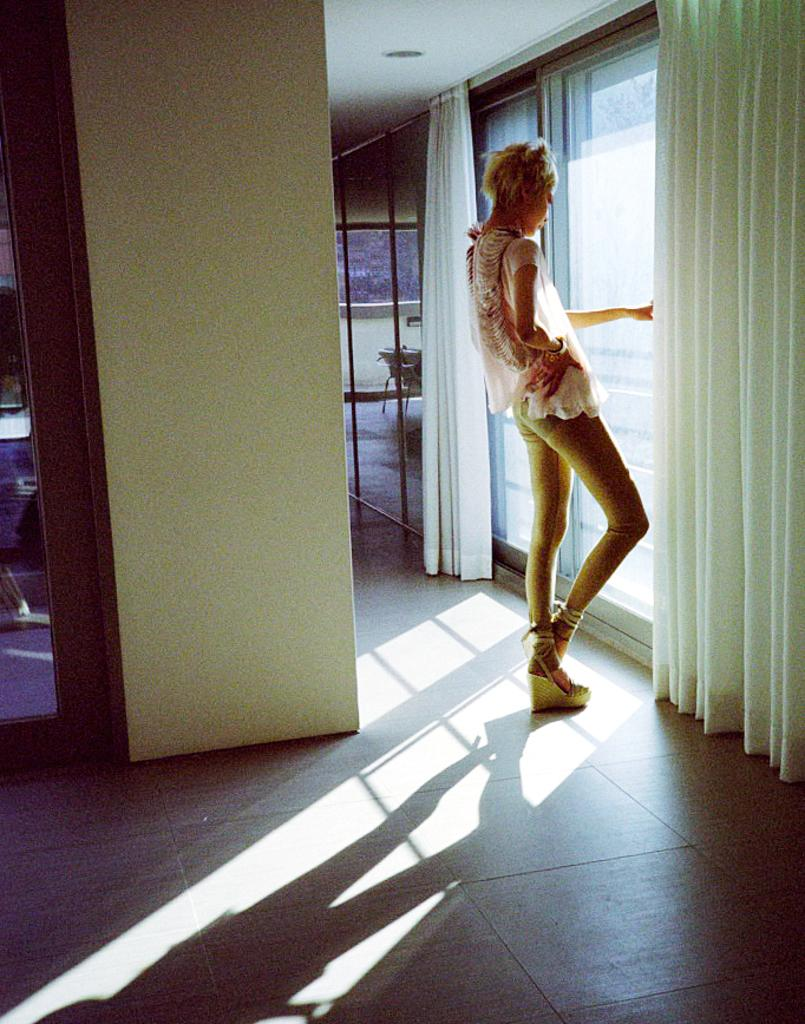What is the main subject in the image? There is a lady standing in the image. What can be seen on the left side of the image? There is a wall on the left side of the image. What is present on the right side of the image? There are windows on the right side of the image. What type of window treatment is visible in the image? There are curtains associated with the windows on the right side of the image. What type of hat is the lady wearing in the image? The lady is not wearing a hat in the image. What year was the image taken? The provided facts do not include information about the year the image was taken. 